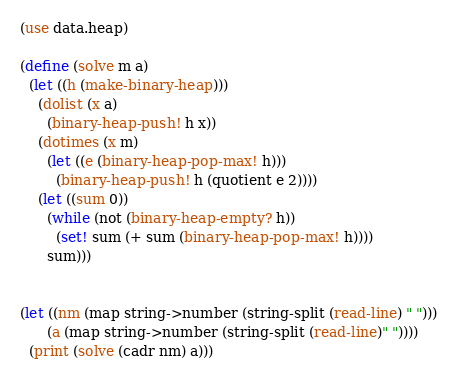<code> <loc_0><loc_0><loc_500><loc_500><_Scheme_>(use data.heap)

(define (solve m a)
  (let ((h (make-binary-heap)))
    (dolist (x a)
      (binary-heap-push! h x))
    (dotimes (x m)
      (let ((e (binary-heap-pop-max! h)))
        (binary-heap-push! h (quotient e 2))))
    (let ((sum 0))
      (while (not (binary-heap-empty? h))
        (set! sum (+ sum (binary-heap-pop-max! h))))
      sum)))


(let ((nm (map string->number (string-split (read-line) " ")))
      (a (map string->number (string-split (read-line)" "))))
  (print (solve (cadr nm) a)))
</code> 